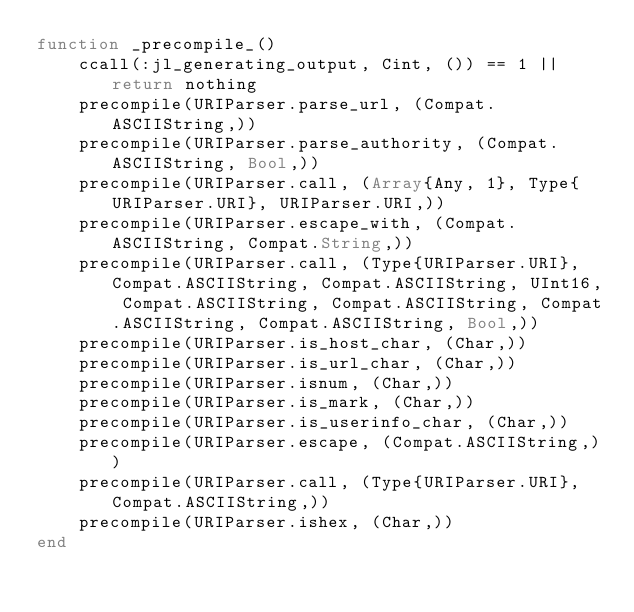<code> <loc_0><loc_0><loc_500><loc_500><_Julia_>function _precompile_()
    ccall(:jl_generating_output, Cint, ()) == 1 || return nothing
    precompile(URIParser.parse_url, (Compat.ASCIIString,))
    precompile(URIParser.parse_authority, (Compat.ASCIIString, Bool,))
    precompile(URIParser.call, (Array{Any, 1}, Type{URIParser.URI}, URIParser.URI,))
    precompile(URIParser.escape_with, (Compat.ASCIIString, Compat.String,))
    precompile(URIParser.call, (Type{URIParser.URI}, Compat.ASCIIString, Compat.ASCIIString, UInt16, Compat.ASCIIString, Compat.ASCIIString, Compat.ASCIIString, Compat.ASCIIString, Bool,))
    precompile(URIParser.is_host_char, (Char,))
    precompile(URIParser.is_url_char, (Char,))
    precompile(URIParser.isnum, (Char,))
    precompile(URIParser.is_mark, (Char,))
    precompile(URIParser.is_userinfo_char, (Char,))
    precompile(URIParser.escape, (Compat.ASCIIString,))
    precompile(URIParser.call, (Type{URIParser.URI}, Compat.ASCIIString,))
    precompile(URIParser.ishex, (Char,))
end
</code> 